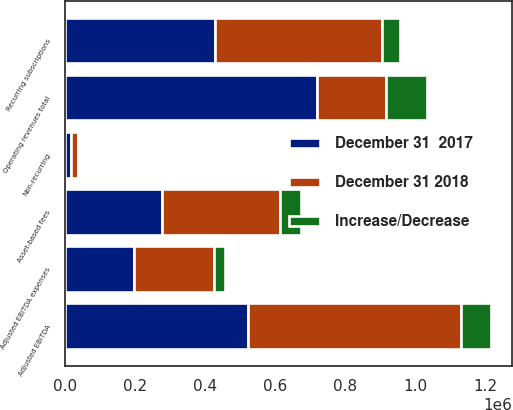<chart> <loc_0><loc_0><loc_500><loc_500><stacked_bar_chart><ecel><fcel>Recurring subscriptions<fcel>Asset-based fees<fcel>Non-recurring<fcel>Operating revenues total<fcel>Adjusted EBITDA expenses<fcel>Adjusted EBITDA<nl><fcel>December 31 2018<fcel>477612<fcel>336565<fcel>21298<fcel>196718<fcel>227622<fcel>607853<nl><fcel>December 31  2017<fcel>427289<fcel>276092<fcel>15578<fcel>718959<fcel>196718<fcel>522241<nl><fcel>Increase/Decrease<fcel>50323<fcel>60473<fcel>5720<fcel>116516<fcel>30904<fcel>85612<nl></chart> 